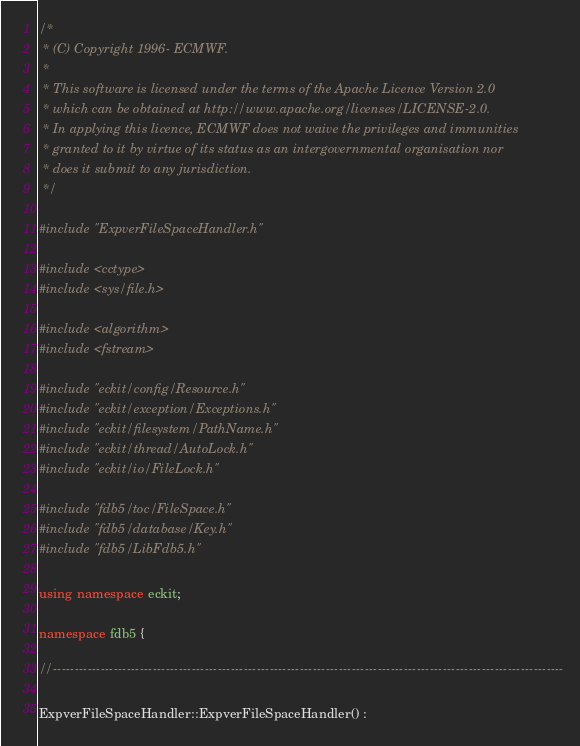<code> <loc_0><loc_0><loc_500><loc_500><_C++_>/*
 * (C) Copyright 1996- ECMWF.
 *
 * This software is licensed under the terms of the Apache Licence Version 2.0
 * which can be obtained at http://www.apache.org/licenses/LICENSE-2.0.
 * In applying this licence, ECMWF does not waive the privileges and immunities
 * granted to it by virtue of its status as an intergovernmental organisation nor
 * does it submit to any jurisdiction.
 */

#include "ExpverFileSpaceHandler.h"

#include <cctype> 
#include <sys/file.h>

#include <algorithm>
#include <fstream>

#include "eckit/config/Resource.h"
#include "eckit/exception/Exceptions.h"
#include "eckit/filesystem/PathName.h"
#include "eckit/thread/AutoLock.h"
#include "eckit/io/FileLock.h"

#include "fdb5/toc/FileSpace.h"
#include "fdb5/database/Key.h"
#include "fdb5/LibFdb5.h"

using namespace eckit;

namespace fdb5 {

//----------------------------------------------------------------------------------------------------------------------

ExpverFileSpaceHandler::ExpverFileSpaceHandler() :</code> 